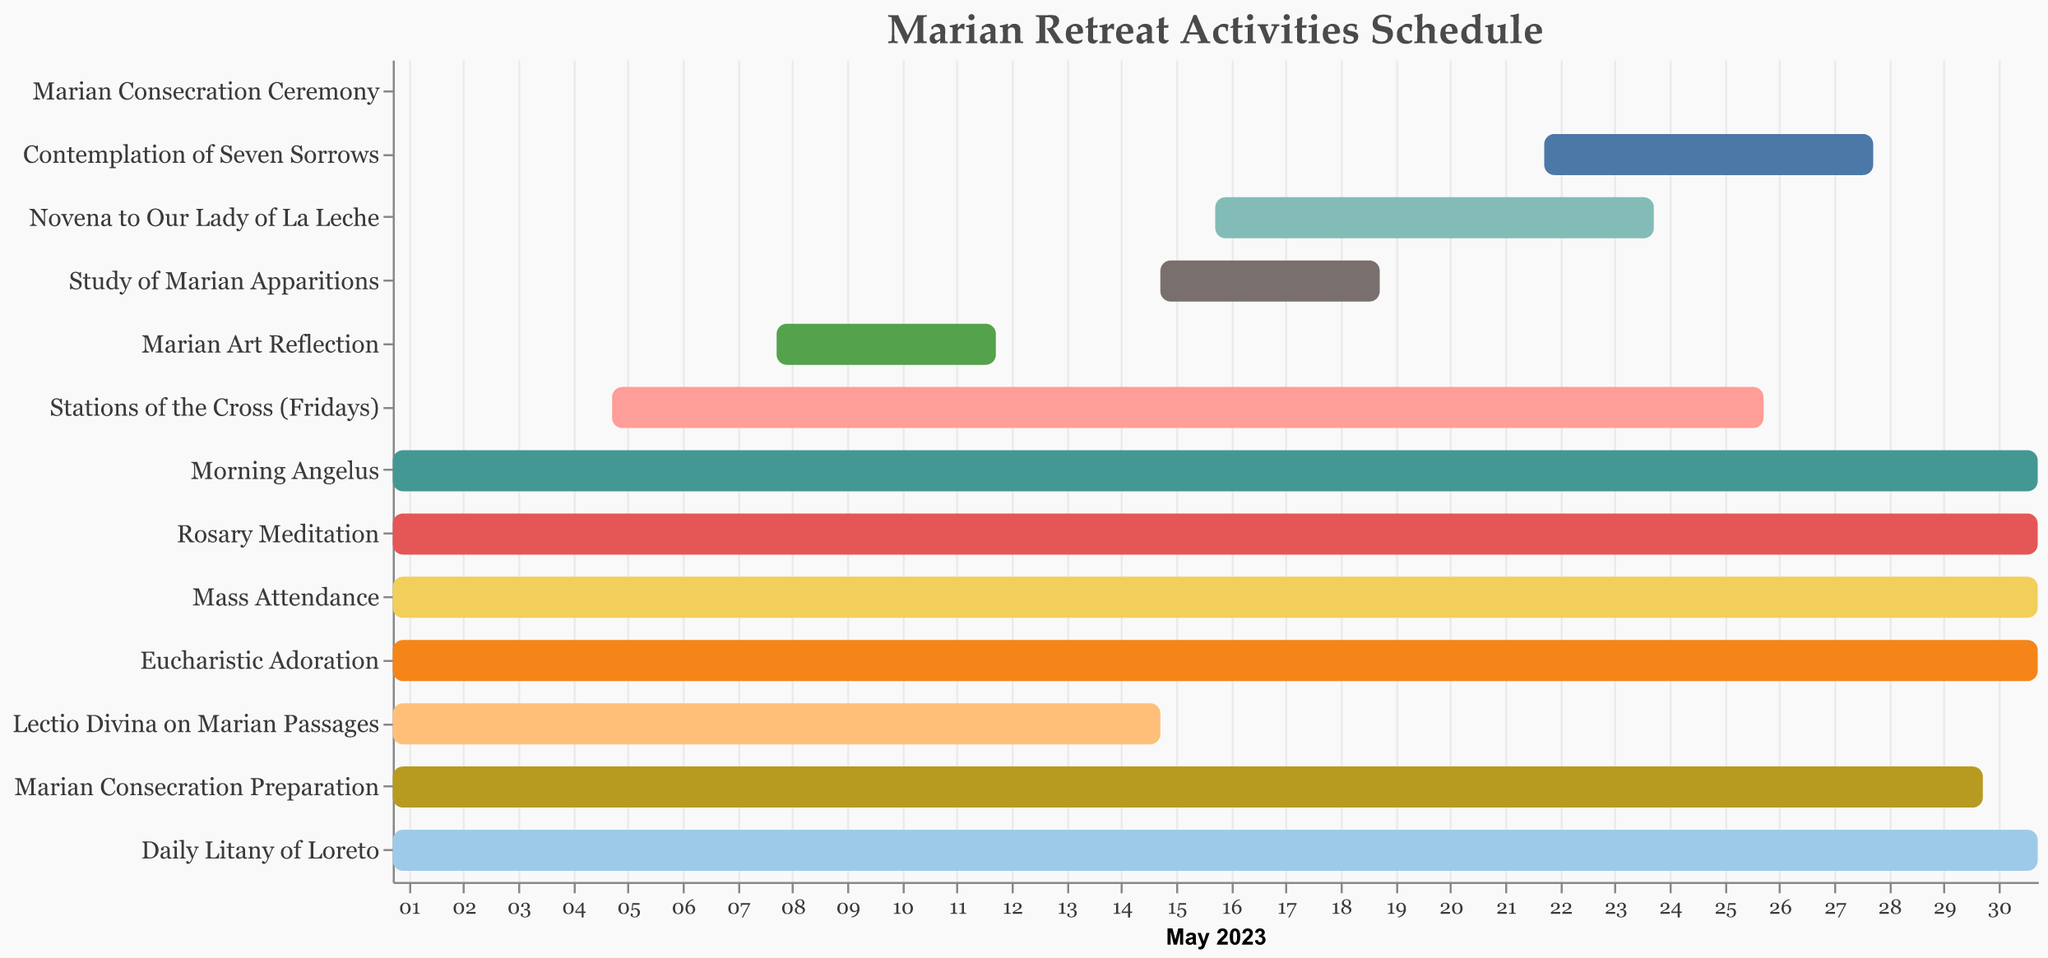What's the total duration for "Marian Art Reflection"? The task "Marian Art Reflection" starts on May 8 and ends on May 12. The total duration in days can be calculated as End Date - Start Date + 1. Therefore, the duration is 12 - 8 + 1 = 5 days.
Answer: 5 Which task has the longest duration? The tasks "Morning Angelus," "Rosary Meditation," "Mass Attendance," "Eucharistic Adoration," and "Daily Litany of Loreto" all start on May 1 and end on May 31, so they all have the longest duration of 31 days.
Answer: Morning Angelus, Rosary Meditation, Mass Attendance, Eucharistic Adoration, Daily Litany of Loreto How many tasks are scheduled to start on May 1? By examining the Start Date for each activity, we notice that the tasks "Morning Angelus," "Rosary Meditation," "Mass Attendance," "Eucharistic Adoration," "Lectio Divina on Marian Passages," "Marian Consecration Preparation," and "Daily Litany of Loreto" all begin on May 1. Thus, there are 7 tasks starting on May 1.
Answer: 7 Which activity has the shortest duration, and what is its duration? To find the activity with the shortest duration, we look at the duration column. The "Marian Consecration Ceremony" only has a duration of 1 day.
Answer: Marian Consecration Ceremony, 1 day What is the exact date range for "Stations of the Cross (Fridays)"? The "Stations of the Cross (Fridays)" task starts on May 5 and ends on May 26. Hence, the exact date range is from May 5 to May 26.
Answer: May 5 to May 26 When does "Novena to Our Lady of La Leche" take place, and how long does it last? The task "Novena to Our Lady of La Leche" starts on May 16 and ends on May 24. The duration is calculated as 24 - 16 + 1 = 9 days.
Answer: May 16 to May 24, 9 days Compare the durations of "Lectio Divina on Marian Passages" and "Study of Marian Apparitions." Which one is longer and by how much? "Lectio Divina on Marian Passages" lasts for 15 days (May 1 to May 15), while "Study of Marian Apparitions" lasts for 5 days (May 15 to May 19). The difference in duration is 15 - 5 = 10 days, making "Lectio Divina on Marian Passages" longer.
Answer: Lectio Divina on Marian Passages, 10 days How many activities are planned to be carried out in the entire month of May? By checking the Task column, we count that there are a total of 13 activities planned during the entire month of May.
Answer: 13 